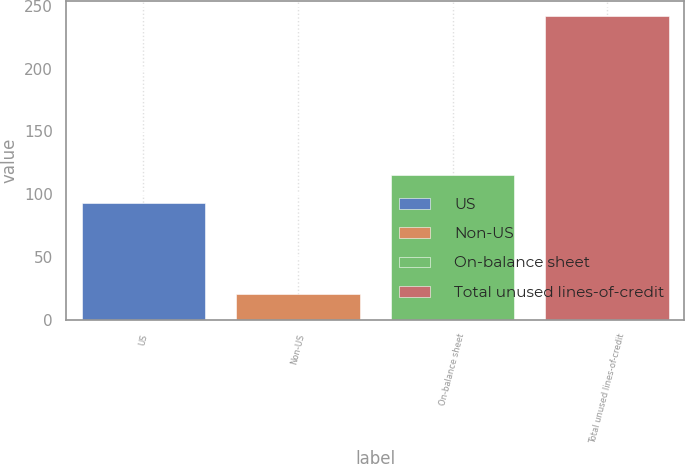Convert chart. <chart><loc_0><loc_0><loc_500><loc_500><bar_chart><fcel>US<fcel>Non-US<fcel>On-balance sheet<fcel>Total unused lines-of-credit<nl><fcel>93<fcel>20<fcel>115.2<fcel>242<nl></chart> 